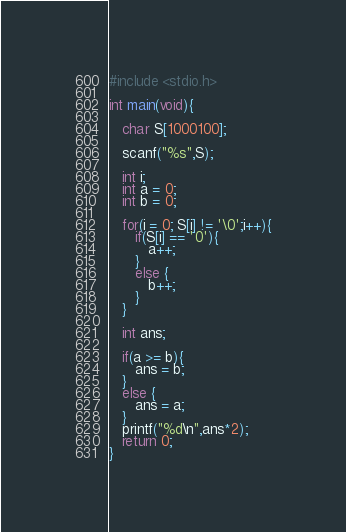Convert code to text. <code><loc_0><loc_0><loc_500><loc_500><_C_>#include <stdio.h>

int main(void){
   
   char S[1000100];
   
   scanf("%s",S);
   
   int i;
   int a = 0;
   int b = 0;
   
   for(i = 0; S[i] != '\0';i++){
      if(S[i] == '0'){
         a++;
      }
      else {
         b++;
      }
   }
   
   int ans;
   
   if(a >= b){
      ans = b;
   }
   else {
      ans = a;
   }
   printf("%d\n",ans*2);
   return 0;
}
</code> 